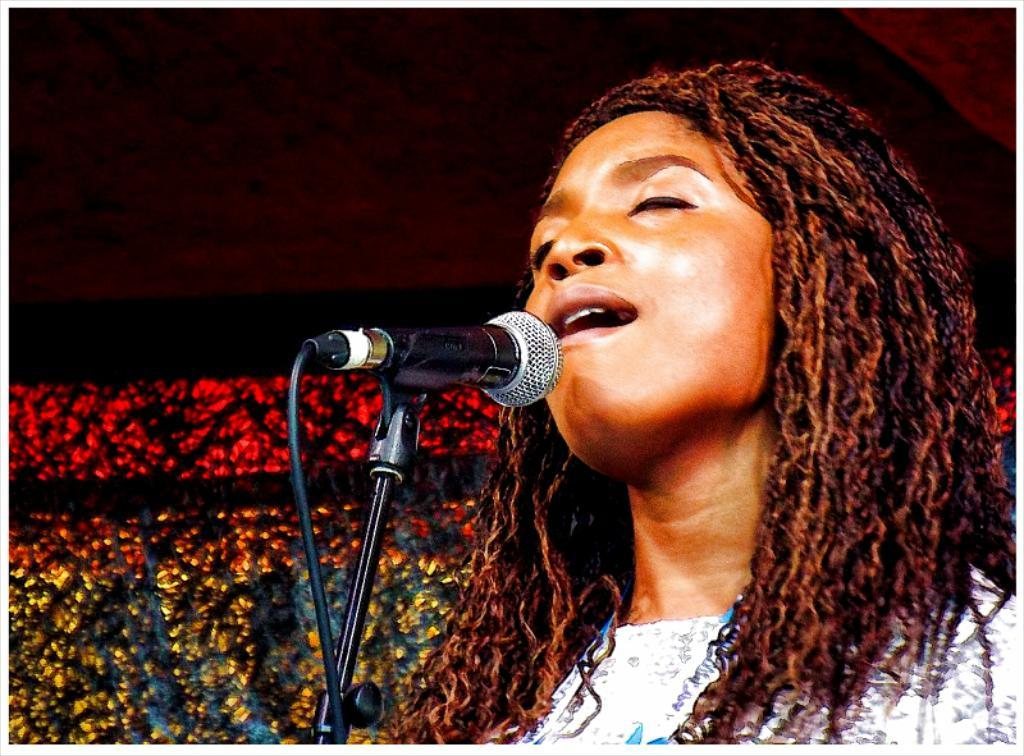What is the person in the image doing? The person is singing. What object is the person using while singing? The person is in front of a microphone. What is the person wearing in the image? The person is wearing a white shirt. What can be seen in the background of the image? There are lights visible in the background of the image. Reasoning: Let's think step by step by step in order to produce the conversation. We start by identifying the main subject in the image, which is the person singing. Then, we expand the conversation to include the object the person is using (the microphone) and their clothing (the white shirt). Finally, we describe the background of the image, which includes lights. Each question is designed to elicit a specific detail about the image that is known from the provided facts. Absurd Question/Answer: How many toes does the person have on their left foot in the image? There is no information about the person's toes in the image, so we cannot determine the number of toes on their left foot. 